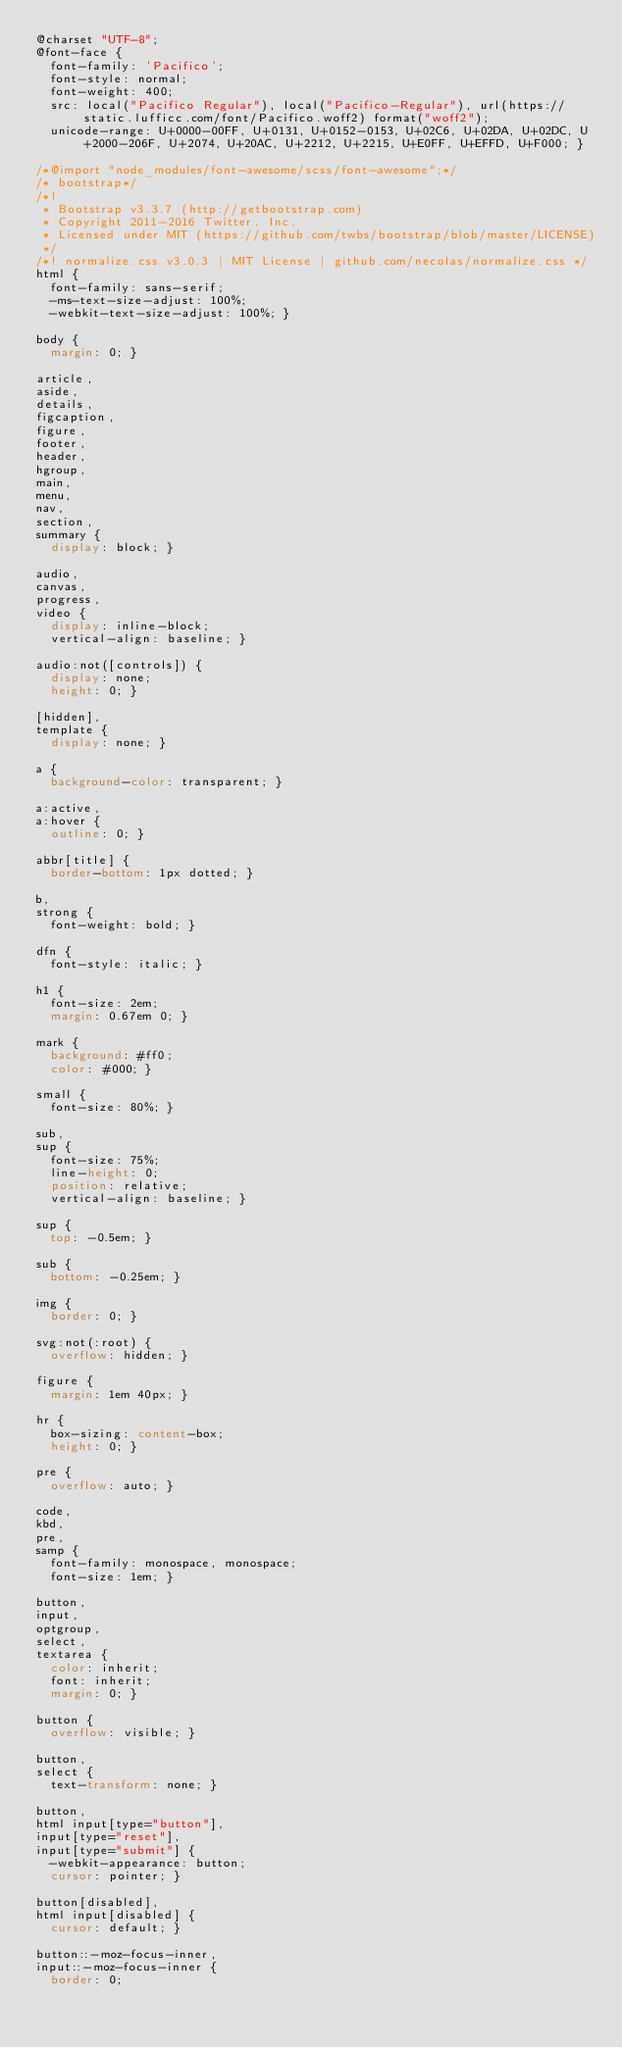Convert code to text. <code><loc_0><loc_0><loc_500><loc_500><_CSS_>@charset "UTF-8";
@font-face {
  font-family: 'Pacifico';
  font-style: normal;
  font-weight: 400;
  src: local("Pacifico Regular"), local("Pacifico-Regular"), url(https://static.lufficc.com/font/Pacifico.woff2) format("woff2");
  unicode-range: U+0000-00FF, U+0131, U+0152-0153, U+02C6, U+02DA, U+02DC, U+2000-206F, U+2074, U+20AC, U+2212, U+2215, U+E0FF, U+EFFD, U+F000; }

/*@import "node_modules/font-awesome/scss/font-awesome";*/
/* bootstrap*/
/*!
 * Bootstrap v3.3.7 (http://getbootstrap.com)
 * Copyright 2011-2016 Twitter, Inc.
 * Licensed under MIT (https://github.com/twbs/bootstrap/blob/master/LICENSE)
 */
/*! normalize.css v3.0.3 | MIT License | github.com/necolas/normalize.css */
html {
  font-family: sans-serif;
  -ms-text-size-adjust: 100%;
  -webkit-text-size-adjust: 100%; }

body {
  margin: 0; }

article,
aside,
details,
figcaption,
figure,
footer,
header,
hgroup,
main,
menu,
nav,
section,
summary {
  display: block; }

audio,
canvas,
progress,
video {
  display: inline-block;
  vertical-align: baseline; }

audio:not([controls]) {
  display: none;
  height: 0; }

[hidden],
template {
  display: none; }

a {
  background-color: transparent; }

a:active,
a:hover {
  outline: 0; }

abbr[title] {
  border-bottom: 1px dotted; }

b,
strong {
  font-weight: bold; }

dfn {
  font-style: italic; }

h1 {
  font-size: 2em;
  margin: 0.67em 0; }

mark {
  background: #ff0;
  color: #000; }

small {
  font-size: 80%; }

sub,
sup {
  font-size: 75%;
  line-height: 0;
  position: relative;
  vertical-align: baseline; }

sup {
  top: -0.5em; }

sub {
  bottom: -0.25em; }

img {
  border: 0; }

svg:not(:root) {
  overflow: hidden; }

figure {
  margin: 1em 40px; }

hr {
  box-sizing: content-box;
  height: 0; }

pre {
  overflow: auto; }

code,
kbd,
pre,
samp {
  font-family: monospace, monospace;
  font-size: 1em; }

button,
input,
optgroup,
select,
textarea {
  color: inherit;
  font: inherit;
  margin: 0; }

button {
  overflow: visible; }

button,
select {
  text-transform: none; }

button,
html input[type="button"],
input[type="reset"],
input[type="submit"] {
  -webkit-appearance: button;
  cursor: pointer; }

button[disabled],
html input[disabled] {
  cursor: default; }

button::-moz-focus-inner,
input::-moz-focus-inner {
  border: 0;</code> 